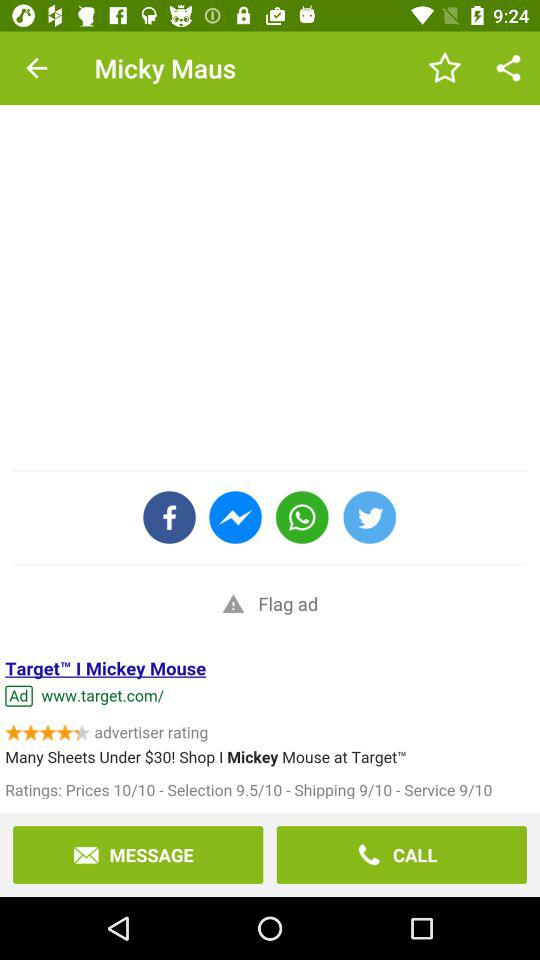What's the rating for the price? The rating for the price is 10. 